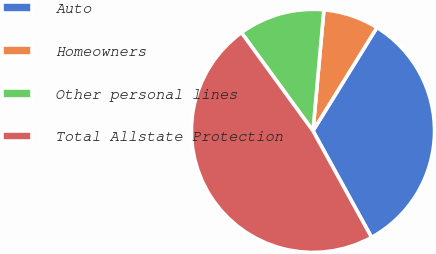<chart> <loc_0><loc_0><loc_500><loc_500><pie_chart><fcel>Auto<fcel>Homeowners<fcel>Other personal lines<fcel>Total Allstate Protection<nl><fcel>33.18%<fcel>7.39%<fcel>11.45%<fcel>47.99%<nl></chart> 